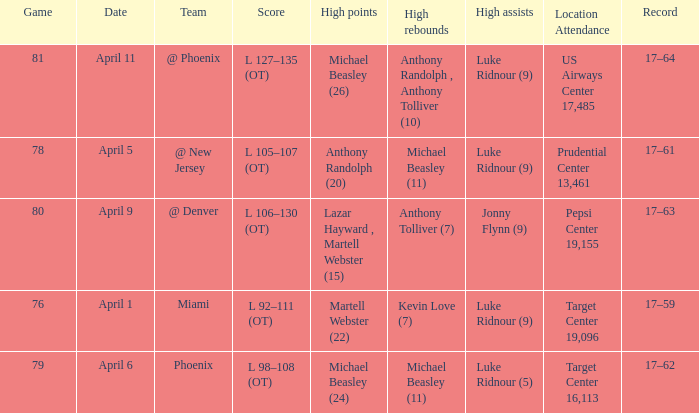In how many different games did Luke Ridnour (5) did the most high assists? 1.0. 